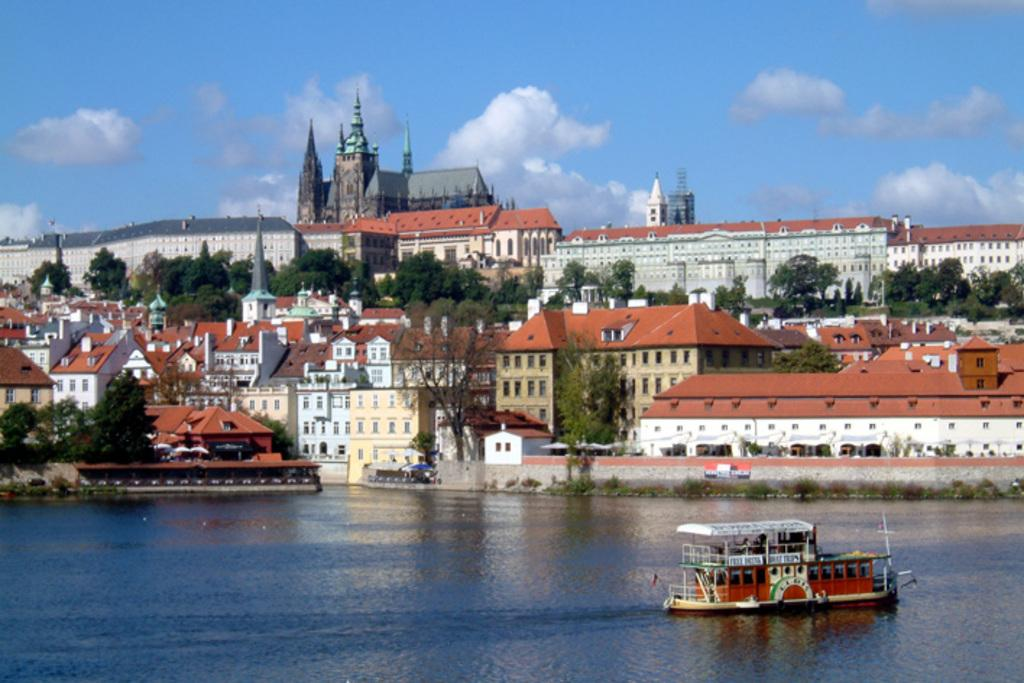What is the main subject of the image? The main subject of the image is a boat. Where is the boat located? The boat is on water. What can be seen in the background of the image? There are buildings, trees, and the sky visible in the background of the image. How much money is the girl holding in the image? There is no girl present in the image, and therefore no money can be observed. Are there any ants visible on the boat in the image? There are no ants visible on the boat in the image. 